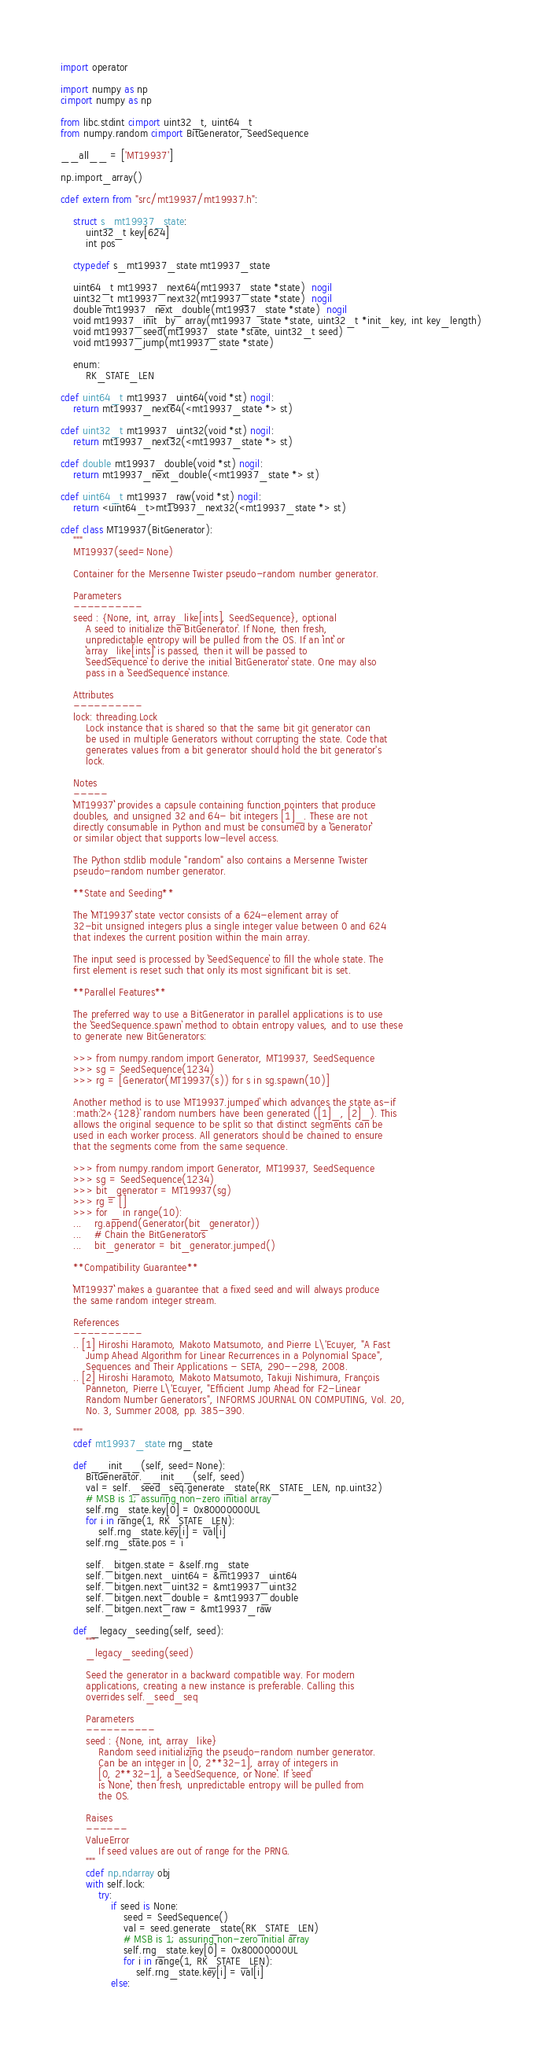<code> <loc_0><loc_0><loc_500><loc_500><_Cython_>import operator

import numpy as np
cimport numpy as np

from libc.stdint cimport uint32_t, uint64_t
from numpy.random cimport BitGenerator, SeedSequence

__all__ = ['MT19937']

np.import_array()

cdef extern from "src/mt19937/mt19937.h":

    struct s_mt19937_state:
        uint32_t key[624]
        int pos

    ctypedef s_mt19937_state mt19937_state

    uint64_t mt19937_next64(mt19937_state *state)  nogil
    uint32_t mt19937_next32(mt19937_state *state)  nogil
    double mt19937_next_double(mt19937_state *state)  nogil
    void mt19937_init_by_array(mt19937_state *state, uint32_t *init_key, int key_length)
    void mt19937_seed(mt19937_state *state, uint32_t seed)
    void mt19937_jump(mt19937_state *state)

    enum:
        RK_STATE_LEN

cdef uint64_t mt19937_uint64(void *st) nogil:
    return mt19937_next64(<mt19937_state *> st)

cdef uint32_t mt19937_uint32(void *st) nogil:
    return mt19937_next32(<mt19937_state *> st)

cdef double mt19937_double(void *st) nogil:
    return mt19937_next_double(<mt19937_state *> st)

cdef uint64_t mt19937_raw(void *st) nogil:
    return <uint64_t>mt19937_next32(<mt19937_state *> st)

cdef class MT19937(BitGenerator):
    """
    MT19937(seed=None)

    Container for the Mersenne Twister pseudo-random number generator.

    Parameters
    ----------
    seed : {None, int, array_like[ints], SeedSequence}, optional
        A seed to initialize the `BitGenerator`. If None, then fresh,
        unpredictable entropy will be pulled from the OS. If an ``int`` or
        ``array_like[ints]`` is passed, then it will be passed to
        `SeedSequence` to derive the initial `BitGenerator` state. One may also
        pass in a `SeedSequence` instance.

    Attributes
    ----------
    lock: threading.Lock
        Lock instance that is shared so that the same bit git generator can
        be used in multiple Generators without corrupting the state. Code that
        generates values from a bit generator should hold the bit generator's
        lock.

    Notes
    -----
    ``MT19937`` provides a capsule containing function pointers that produce
    doubles, and unsigned 32 and 64- bit integers [1]_. These are not
    directly consumable in Python and must be consumed by a ``Generator``
    or similar object that supports low-level access.

    The Python stdlib module "random" also contains a Mersenne Twister
    pseudo-random number generator.

    **State and Seeding**

    The ``MT19937`` state vector consists of a 624-element array of
    32-bit unsigned integers plus a single integer value between 0 and 624
    that indexes the current position within the main array.

    The input seed is processed by `SeedSequence` to fill the whole state. The
    first element is reset such that only its most significant bit is set.

    **Parallel Features**

    The preferred way to use a BitGenerator in parallel applications is to use
    the `SeedSequence.spawn` method to obtain entropy values, and to use these
    to generate new BitGenerators:

    >>> from numpy.random import Generator, MT19937, SeedSequence
    >>> sg = SeedSequence(1234)
    >>> rg = [Generator(MT19937(s)) for s in sg.spawn(10)]

    Another method is to use `MT19937.jumped` which advances the state as-if
    :math:`2^{128}` random numbers have been generated ([1]_, [2]_). This
    allows the original sequence to be split so that distinct segments can be
    used in each worker process. All generators should be chained to ensure
    that the segments come from the same sequence.

    >>> from numpy.random import Generator, MT19937, SeedSequence
    >>> sg = SeedSequence(1234)
    >>> bit_generator = MT19937(sg)
    >>> rg = []
    >>> for _ in range(10):
    ...    rg.append(Generator(bit_generator))
    ...    # Chain the BitGenerators
    ...    bit_generator = bit_generator.jumped()

    **Compatibility Guarantee**

    ``MT19937`` makes a guarantee that a fixed seed and will always produce
    the same random integer stream.

    References
    ----------
    .. [1] Hiroshi Haramoto, Makoto Matsumoto, and Pierre L\'Ecuyer, "A Fast
        Jump Ahead Algorithm for Linear Recurrences in a Polynomial Space",
        Sequences and Their Applications - SETA, 290--298, 2008.
    .. [2] Hiroshi Haramoto, Makoto Matsumoto, Takuji Nishimura, François
        Panneton, Pierre L\'Ecuyer, "Efficient Jump Ahead for F2-Linear
        Random Number Generators", INFORMS JOURNAL ON COMPUTING, Vol. 20,
        No. 3, Summer 2008, pp. 385-390.

    """
    cdef mt19937_state rng_state

    def __init__(self, seed=None):
        BitGenerator.__init__(self, seed)
        val = self._seed_seq.generate_state(RK_STATE_LEN, np.uint32)
        # MSB is 1; assuring non-zero initial array
        self.rng_state.key[0] = 0x80000000UL
        for i in range(1, RK_STATE_LEN):
            self.rng_state.key[i] = val[i]
        self.rng_state.pos = i

        self._bitgen.state = &self.rng_state
        self._bitgen.next_uint64 = &mt19937_uint64
        self._bitgen.next_uint32 = &mt19937_uint32
        self._bitgen.next_double = &mt19937_double
        self._bitgen.next_raw = &mt19937_raw

    def _legacy_seeding(self, seed):
        """
        _legacy_seeding(seed)

        Seed the generator in a backward compatible way. For modern
        applications, creating a new instance is preferable. Calling this
        overrides self._seed_seq

        Parameters
        ----------
        seed : {None, int, array_like}
            Random seed initializing the pseudo-random number generator.
            Can be an integer in [0, 2**32-1], array of integers in
            [0, 2**32-1], a `SeedSequence, or ``None``. If `seed`
            is ``None``, then fresh, unpredictable entropy will be pulled from
            the OS.

        Raises
        ------
        ValueError
            If seed values are out of range for the PRNG.
        """
        cdef np.ndarray obj
        with self.lock:
            try:
                if seed is None:
                    seed = SeedSequence()
                    val = seed.generate_state(RK_STATE_LEN)
                    # MSB is 1; assuring non-zero initial array
                    self.rng_state.key[0] = 0x80000000UL
                    for i in range(1, RK_STATE_LEN):
                        self.rng_state.key[i] = val[i]
                else:</code> 